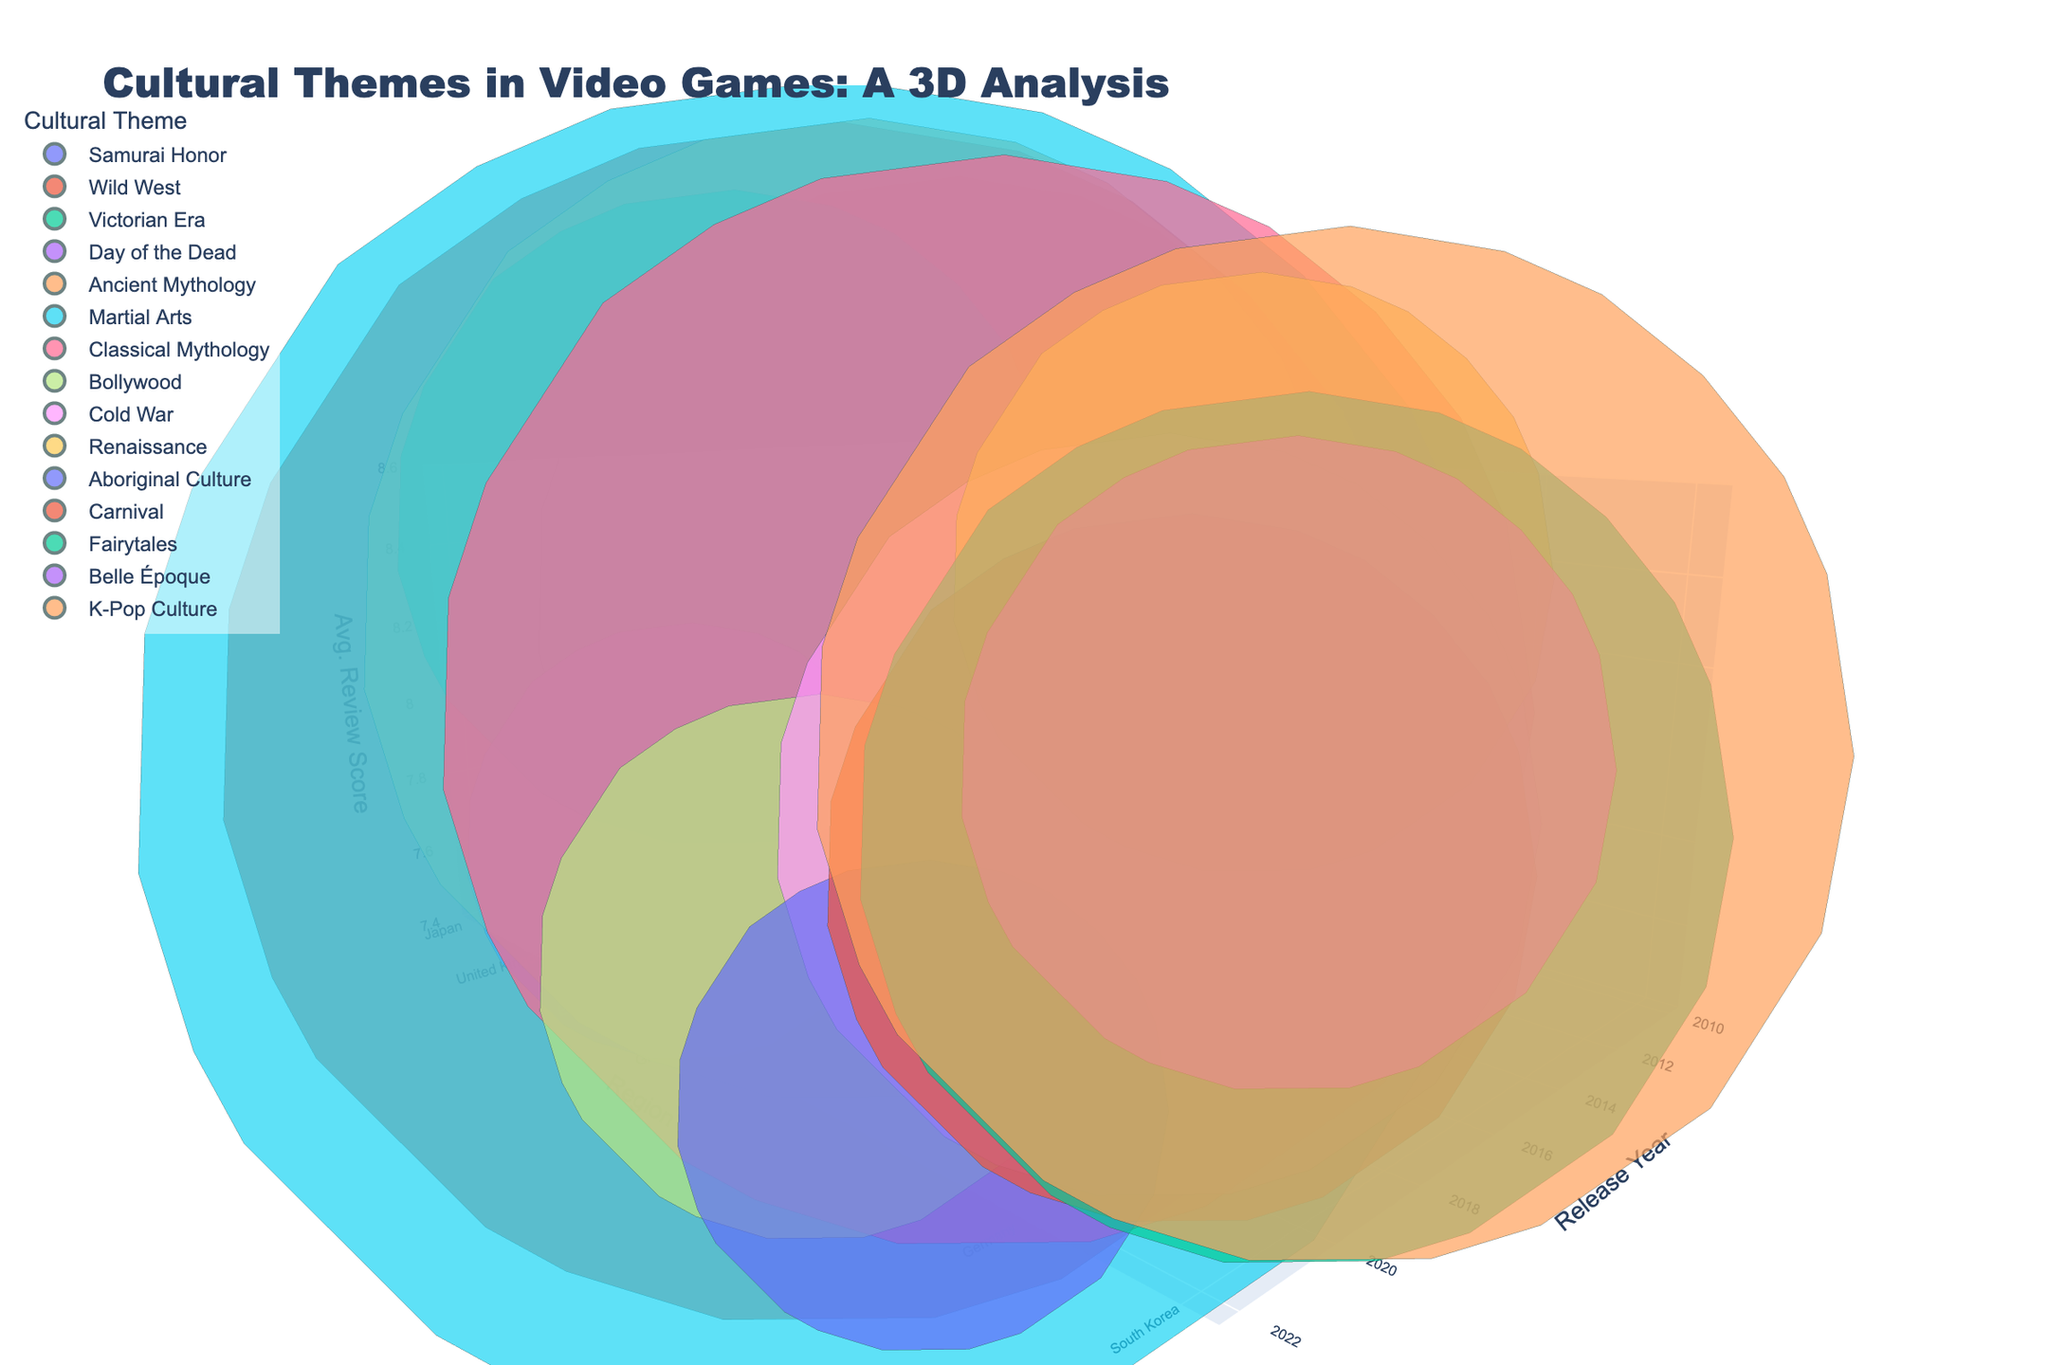What is the title of the 3D bubble chart? The title is located at the top of the figure. It can be read easily as it is clearly labelled in a prominent and larger font size.
Answer: Cultural Themes in Video Games: A 3D Analysis Which region has the highest average review score in the chart? To identify this, look at the 'Avg. Review Score' axis (z-axis) and find the highest bubble point. Then, follow it to its corresponding region (y-axis).
Answer: United Kingdom What cultural theme has the largest game count? The bubble size represents the game count. The largest bubble will indicate the theme with the highest count. Find the largest bubble and identify its cultural theme from the figure legend or hover text.
Answer: Martial Arts How many regions have a cultural theme related to mythology? Look at the different cultural themes and identify how many include the term "mythology" which can be distinguished visually by their colors and legends in the chart.
Answer: Three (Egypt, Greece, Germany) Which region had games released in both 2019 and 2020? Reference the x-axis for the years and identify bubbles corresponding to 2019 and 2020. Then, check the y-axis for consistent regions between the two years.
Answer: South Korea What is the range of average review scores displayed on the z-axis? To identify this, look at the labels on the z-axis at the front of the figure. They indicate the lowest and highest average review scores.
Answer: 7.4 to 8.6 Which year appears to have the most diverse set of cultural themes? Examine the x-axis (Year) and count the number of different colored bubbles representing unique cultural themes for each year. The year with the most distinct colors will be the correct answer.
Answer: 2019 What is the difference in average review score between games from the United States and Japan? Locate the bubbles corresponding to the United States and Japan. Then, read their z-values and calculate the difference between the average review scores.
Answer: 0.3 (8.2 - 7.9) Which region has the smallest bubble in the figure and what does it represent? Identify the smallest bubble in terms of size. The bubble size represents game count, so the smallest bubble corresponds to the region with the fewest games. Hover over or reference the legend for details.
Answer: Mexico, Day of the Dead Which cultural theme released most recently has an average review score above 8? Identify the latest year on the x-axis, then find the bubbles with an average review score above 8 on the z-axis. Cross-reference with the cultural themes displayed.
Answer: Aboriginal Culture from Australia (2022) 